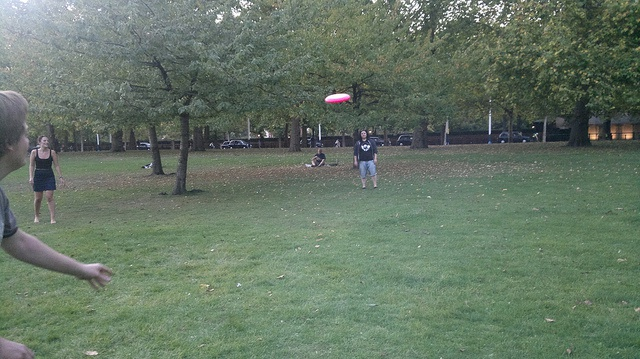Describe the objects in this image and their specific colors. I can see people in lightblue, gray, and darkgray tones, people in lightblue, gray, black, and darkgray tones, people in lightblue, black, gray, and darkgray tones, car in lightblue, black, gray, and darkblue tones, and people in lightblue, gray, and black tones in this image. 